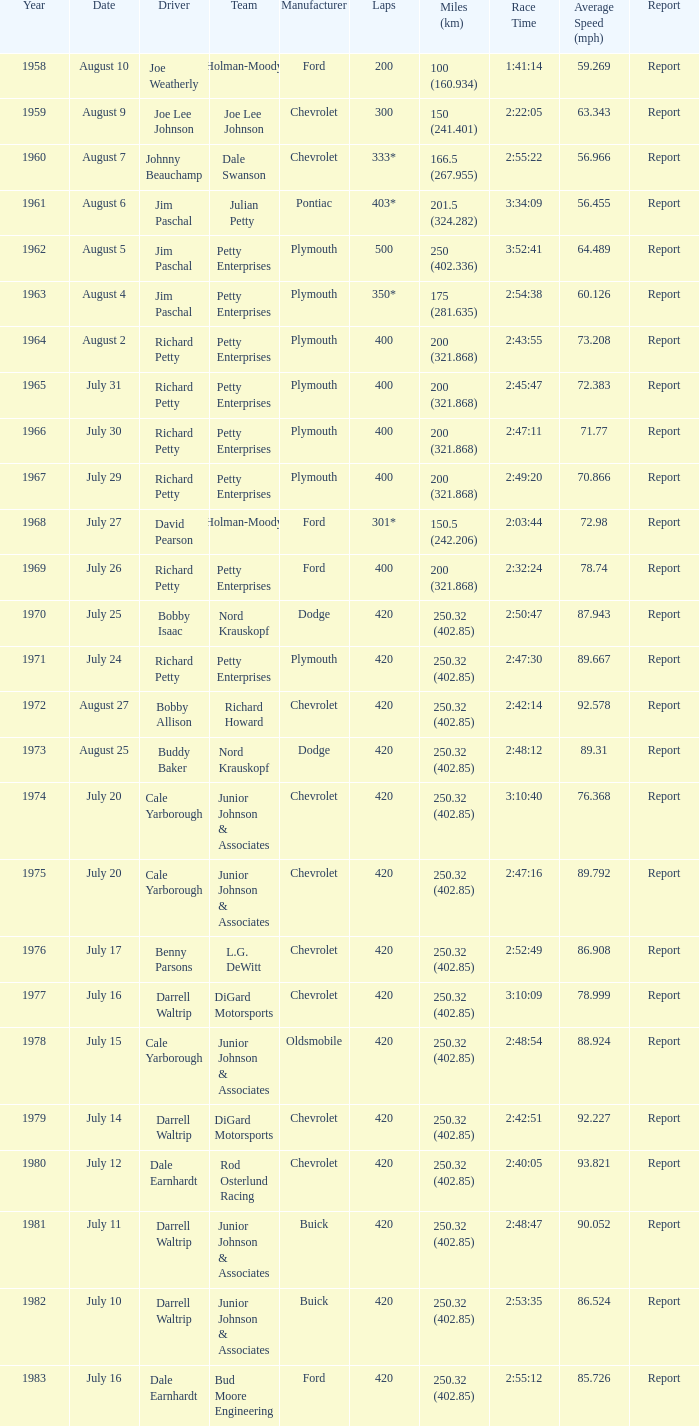What year had a race with 301* laps? 1968.0. 